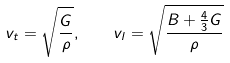<formula> <loc_0><loc_0><loc_500><loc_500>v _ { t } = \sqrt { \frac { G } { \rho } } , \quad v _ { l } = \sqrt { \frac { B + \frac { 4 } { 3 } G } { \rho } }</formula> 